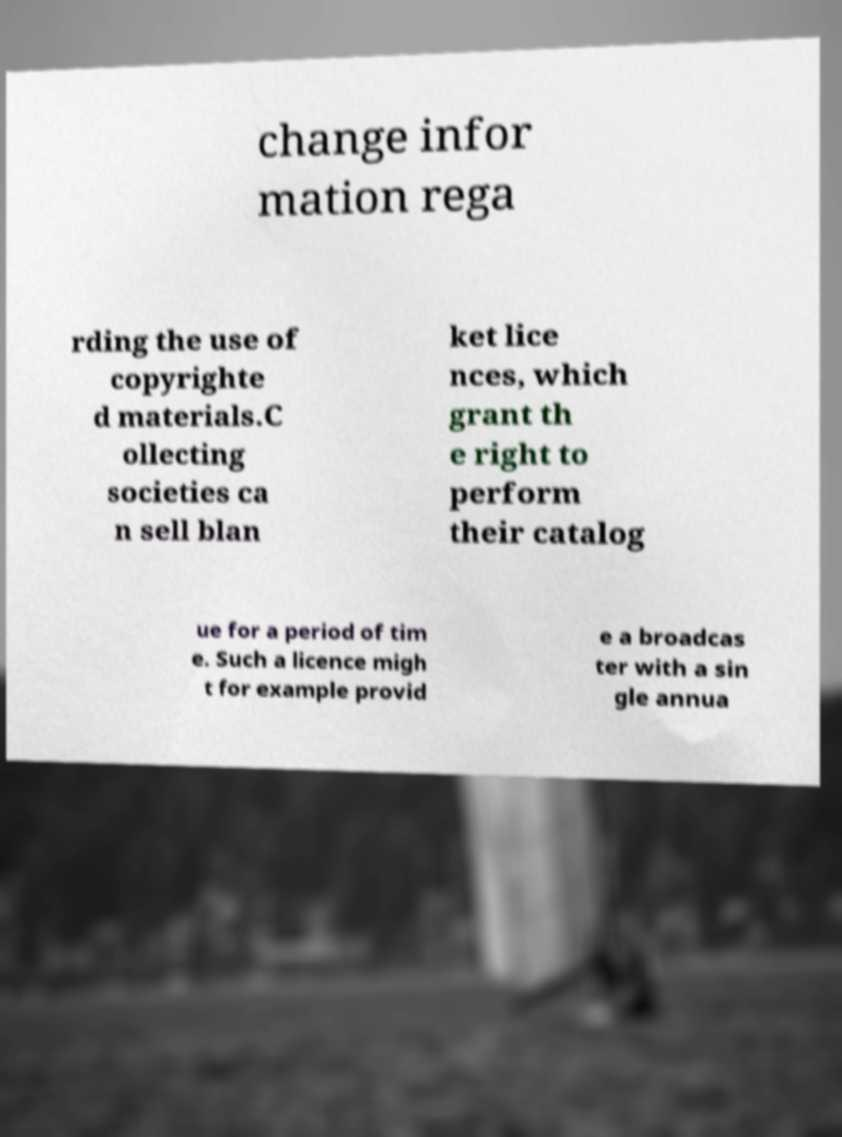What messages or text are displayed in this image? I need them in a readable, typed format. change infor mation rega rding the use of copyrighte d materials.C ollecting societies ca n sell blan ket lice nces, which grant th e right to perform their catalog ue for a period of tim e. Such a licence migh t for example provid e a broadcas ter with a sin gle annua 